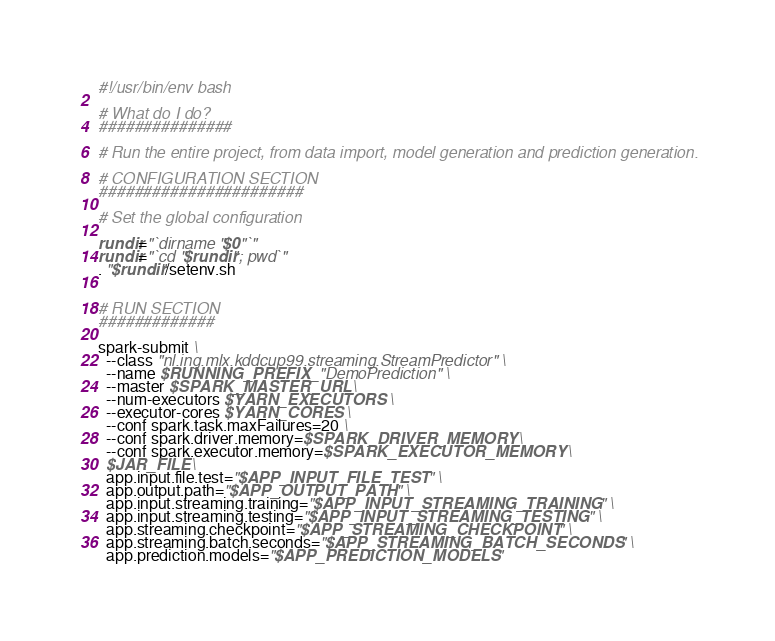Convert code to text. <code><loc_0><loc_0><loc_500><loc_500><_Bash_>#!/usr/bin/env bash

# What do I do?
###############

# Run the entire project, from data import, model generation and prediction generation.

# CONFIGURATION SECTION
#######################

# Set the global configuration

rundir="`dirname "$0"`"
rundir="`cd "$rundir"; pwd`"
. "$rundir"/setenv.sh


# RUN SECTION
#############

spark-submit \
  --class "nl.ing.mlx.kddcup99.streaming.StreamPredictor" \
  --name $RUNNING_PREFIX_"DemoPrediction" \
  --master $SPARK_MASTER_URL \
  --num-executors $YARN_EXECUTORS \
  --executor-cores $YARN_CORES \
  --conf spark.task.maxFailures=20 \
  --conf spark.driver.memory=$SPARK_DRIVER_MEMORY \
  --conf spark.executor.memory=$SPARK_EXECUTOR_MEMORY \
  $JAR_FILE \
  app.input.file.test="$APP_INPUT_FILE_TEST" \
  app.output.path="$APP_OUTPUT_PATH" \
  app.input.streaming.training="$APP_INPUT_STREAMING_TRAINING" \
  app.input.streaming.testing="$APP_INPUT_STREAMING_TESTING" \
  app.streaming.checkpoint="$APP_STREAMING_CHECKPOINT" \
  app.streaming.batch.seconds="$APP_STREAMING_BATCH_SECONDS" \
  app.prediction.models="$APP_PREDICTION_MODELS"
</code> 